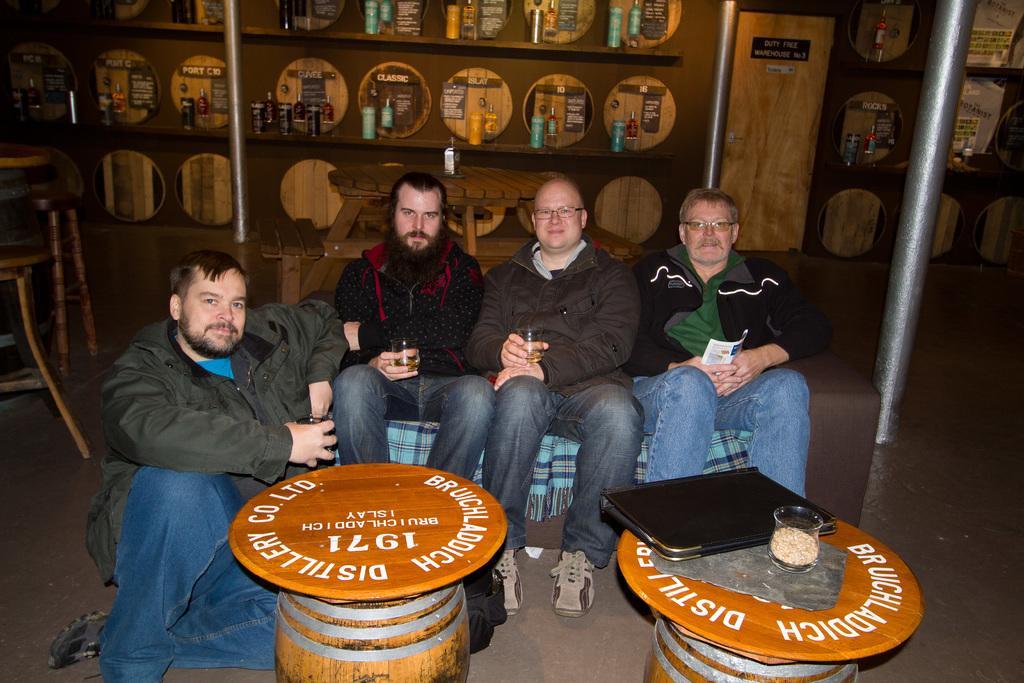In one or two sentences, can you explain what this image depicts? Three people are sitting on the sofa, one person is sitting on the floor behind them there is a table and number of shells where bottles are present in it and the door, in front of the people there are two tables on which a glass jar and a file is present, beside the person there are chairs. 